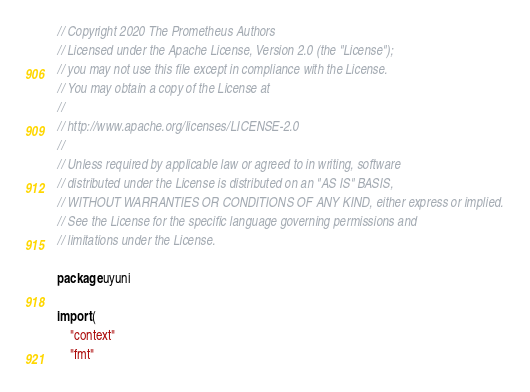<code> <loc_0><loc_0><loc_500><loc_500><_Go_>// Copyright 2020 The Prometheus Authors
// Licensed under the Apache License, Version 2.0 (the "License");
// you may not use this file except in compliance with the License.
// You may obtain a copy of the License at
//
// http://www.apache.org/licenses/LICENSE-2.0
//
// Unless required by applicable law or agreed to in writing, software
// distributed under the License is distributed on an "AS IS" BASIS,
// WITHOUT WARRANTIES OR CONDITIONS OF ANY KIND, either express or implied.
// See the License for the specific language governing permissions and
// limitations under the License.

package uyuni

import (
	"context"
	"fmt"</code> 